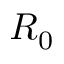<formula> <loc_0><loc_0><loc_500><loc_500>R _ { 0 }</formula> 